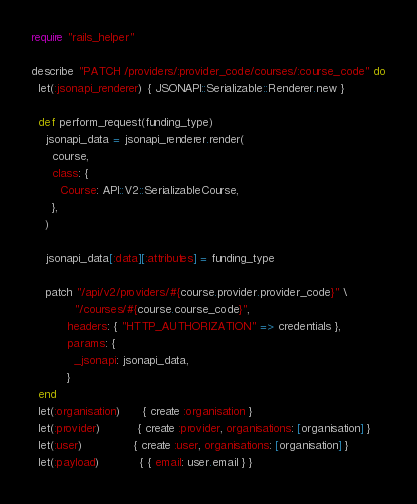<code> <loc_0><loc_0><loc_500><loc_500><_Ruby_>require "rails_helper"

describe "PATCH /providers/:provider_code/courses/:course_code" do
  let(:jsonapi_renderer) { JSONAPI::Serializable::Renderer.new }

  def perform_request(funding_type)
    jsonapi_data = jsonapi_renderer.render(
      course,
      class: {
        Course: API::V2::SerializableCourse,
      },
    )

    jsonapi_data[:data][:attributes] = funding_type

    patch "/api/v2/providers/#{course.provider.provider_code}" \
            "/courses/#{course.course_code}",
          headers: { "HTTP_AUTHORIZATION" => credentials },
          params: {
            _jsonapi: jsonapi_data,
          }
  end
  let(:organisation)      { create :organisation }
  let(:provider)          { create :provider, organisations: [organisation] }
  let(:user)              { create :user, organisations: [organisation] }
  let(:payload)           { { email: user.email } }</code> 